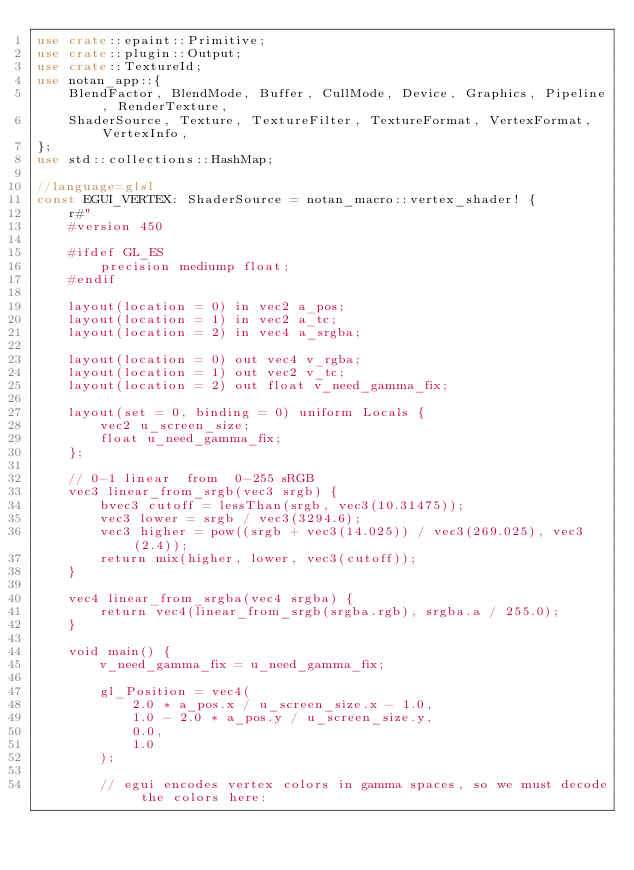<code> <loc_0><loc_0><loc_500><loc_500><_Rust_>use crate::epaint::Primitive;
use crate::plugin::Output;
use crate::TextureId;
use notan_app::{
    BlendFactor, BlendMode, Buffer, CullMode, Device, Graphics, Pipeline, RenderTexture,
    ShaderSource, Texture, TextureFilter, TextureFormat, VertexFormat, VertexInfo,
};
use std::collections::HashMap;

//language=glsl
const EGUI_VERTEX: ShaderSource = notan_macro::vertex_shader! {
    r#"
    #version 450
    
    #ifdef GL_ES
        precision mediump float;
    #endif

    layout(location = 0) in vec2 a_pos;
    layout(location = 1) in vec2 a_tc;
    layout(location = 2) in vec4 a_srgba;

    layout(location = 0) out vec4 v_rgba;
    layout(location = 1) out vec2 v_tc;
    layout(location = 2) out float v_need_gamma_fix;

    layout(set = 0, binding = 0) uniform Locals {
        vec2 u_screen_size;
        float u_need_gamma_fix;
    };

    // 0-1 linear  from  0-255 sRGB
    vec3 linear_from_srgb(vec3 srgb) {
        bvec3 cutoff = lessThan(srgb, vec3(10.31475));
        vec3 lower = srgb / vec3(3294.6);
        vec3 higher = pow((srgb + vec3(14.025)) / vec3(269.025), vec3(2.4));
        return mix(higher, lower, vec3(cutoff));
    }

    vec4 linear_from_srgba(vec4 srgba) {
        return vec4(linear_from_srgb(srgba.rgb), srgba.a / 255.0);
    }

    void main() {
        v_need_gamma_fix = u_need_gamma_fix;

        gl_Position = vec4(
            2.0 * a_pos.x / u_screen_size.x - 1.0,
            1.0 - 2.0 * a_pos.y / u_screen_size.y,
            0.0,
            1.0
        );

        // egui encodes vertex colors in gamma spaces, so we must decode the colors here:</code> 